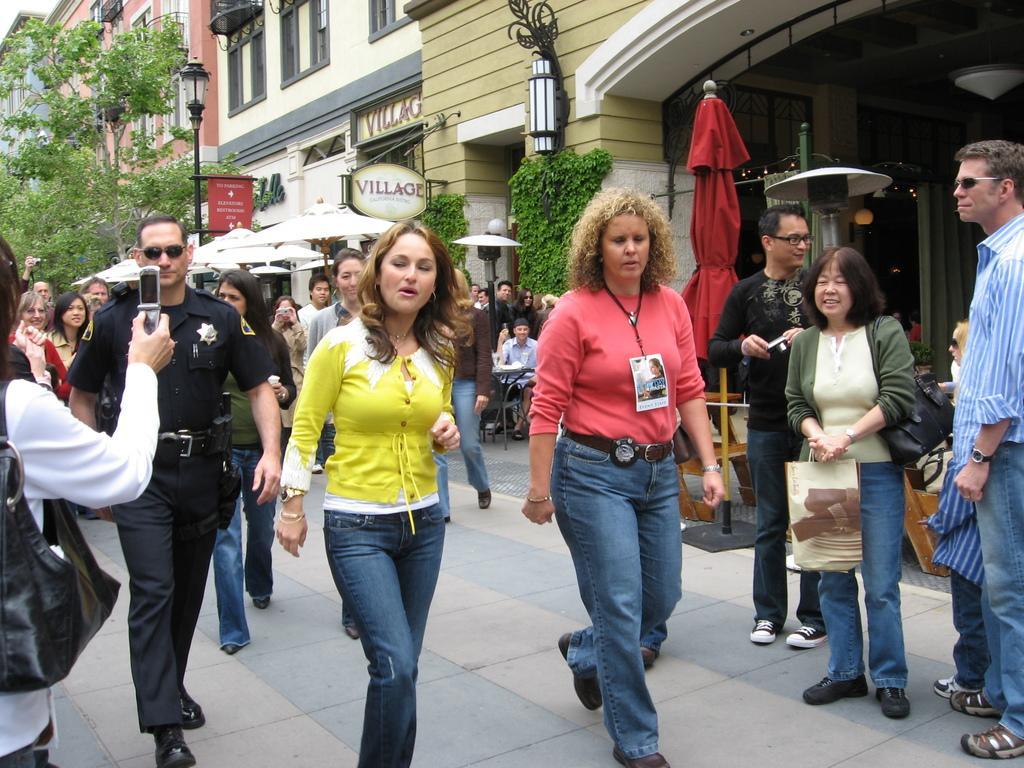Describe this image in one or two sentences. On the left side of the image we can see tree, a person wore a uniform and a lady is holding a cell phone in her hand. In the middle of the image we can see some people, a lady is wearing a tag to her neck and a board is there. On the right side of the image we can see some people and a lady is holding a bag in her hand and a building is there. 